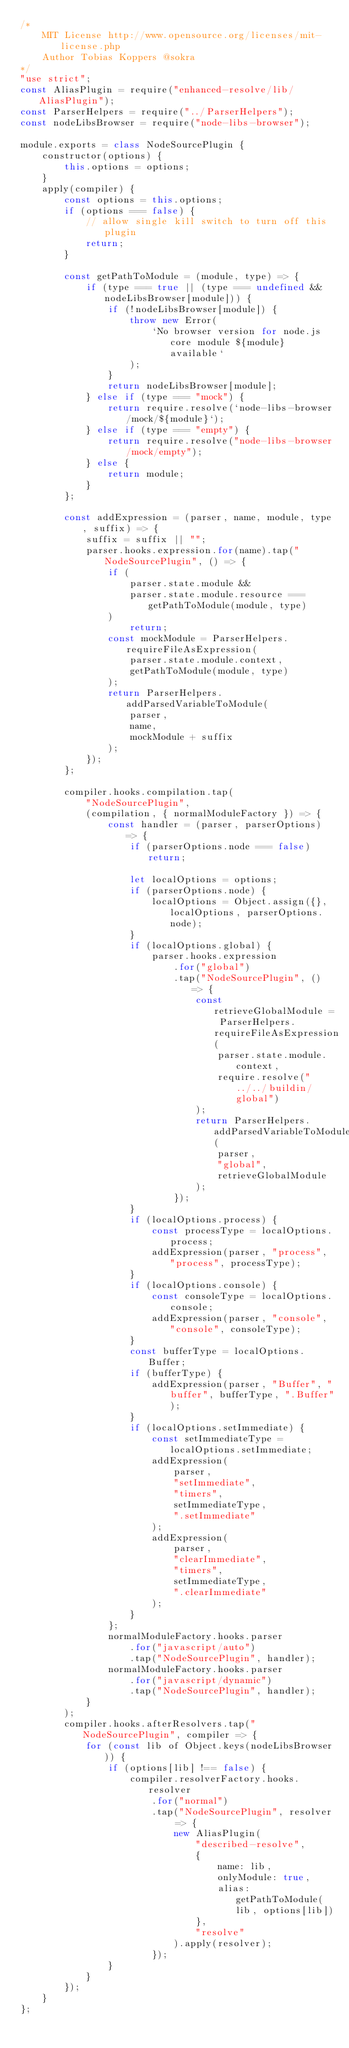Convert code to text. <code><loc_0><loc_0><loc_500><loc_500><_JavaScript_>/*
	MIT License http://www.opensource.org/licenses/mit-license.php
	Author Tobias Koppers @sokra
*/
"use strict";
const AliasPlugin = require("enhanced-resolve/lib/AliasPlugin");
const ParserHelpers = require("../ParserHelpers");
const nodeLibsBrowser = require("node-libs-browser");

module.exports = class NodeSourcePlugin {
	constructor(options) {
		this.options = options;
	}
	apply(compiler) {
		const options = this.options;
		if (options === false) {
			// allow single kill switch to turn off this plugin
			return;
		}

		const getPathToModule = (module, type) => {
			if (type === true || (type === undefined && nodeLibsBrowser[module])) {
				if (!nodeLibsBrowser[module]) {
					throw new Error(
						`No browser version for node.js core module ${module} available`
					);
				}
				return nodeLibsBrowser[module];
			} else if (type === "mock") {
				return require.resolve(`node-libs-browser/mock/${module}`);
			} else if (type === "empty") {
				return require.resolve("node-libs-browser/mock/empty");
			} else {
				return module;
			}
		};

		const addExpression = (parser, name, module, type, suffix) => {
			suffix = suffix || "";
			parser.hooks.expression.for(name).tap("NodeSourcePlugin", () => {
				if (
					parser.state.module &&
					parser.state.module.resource === getPathToModule(module, type)
				)
					return;
				const mockModule = ParserHelpers.requireFileAsExpression(
					parser.state.module.context,
					getPathToModule(module, type)
				);
				return ParserHelpers.addParsedVariableToModule(
					parser,
					name,
					mockModule + suffix
				);
			});
		};

		compiler.hooks.compilation.tap(
			"NodeSourcePlugin",
			(compilation, { normalModuleFactory }) => {
				const handler = (parser, parserOptions) => {
					if (parserOptions.node === false) return;

					let localOptions = options;
					if (parserOptions.node) {
						localOptions = Object.assign({}, localOptions, parserOptions.node);
					}
					if (localOptions.global) {
						parser.hooks.expression
							.for("global")
							.tap("NodeSourcePlugin", () => {
								const retrieveGlobalModule = ParserHelpers.requireFileAsExpression(
									parser.state.module.context,
									require.resolve("../../buildin/global")
								);
								return ParserHelpers.addParsedVariableToModule(
									parser,
									"global",
									retrieveGlobalModule
								);
							});
					}
					if (localOptions.process) {
						const processType = localOptions.process;
						addExpression(parser, "process", "process", processType);
					}
					if (localOptions.console) {
						const consoleType = localOptions.console;
						addExpression(parser, "console", "console", consoleType);
					}
					const bufferType = localOptions.Buffer;
					if (bufferType) {
						addExpression(parser, "Buffer", "buffer", bufferType, ".Buffer");
					}
					if (localOptions.setImmediate) {
						const setImmediateType = localOptions.setImmediate;
						addExpression(
							parser,
							"setImmediate",
							"timers",
							setImmediateType,
							".setImmediate"
						);
						addExpression(
							parser,
							"clearImmediate",
							"timers",
							setImmediateType,
							".clearImmediate"
						);
					}
				};
				normalModuleFactory.hooks.parser
					.for("javascript/auto")
					.tap("NodeSourcePlugin", handler);
				normalModuleFactory.hooks.parser
					.for("javascript/dynamic")
					.tap("NodeSourcePlugin", handler);
			}
		);
		compiler.hooks.afterResolvers.tap("NodeSourcePlugin", compiler => {
			for (const lib of Object.keys(nodeLibsBrowser)) {
				if (options[lib] !== false) {
					compiler.resolverFactory.hooks.resolver
						.for("normal")
						.tap("NodeSourcePlugin", resolver => {
							new AliasPlugin(
								"described-resolve",
								{
									name: lib,
									onlyModule: true,
									alias: getPathToModule(lib, options[lib])
								},
								"resolve"
							).apply(resolver);
						});
				}
			}
		});
	}
};
</code> 